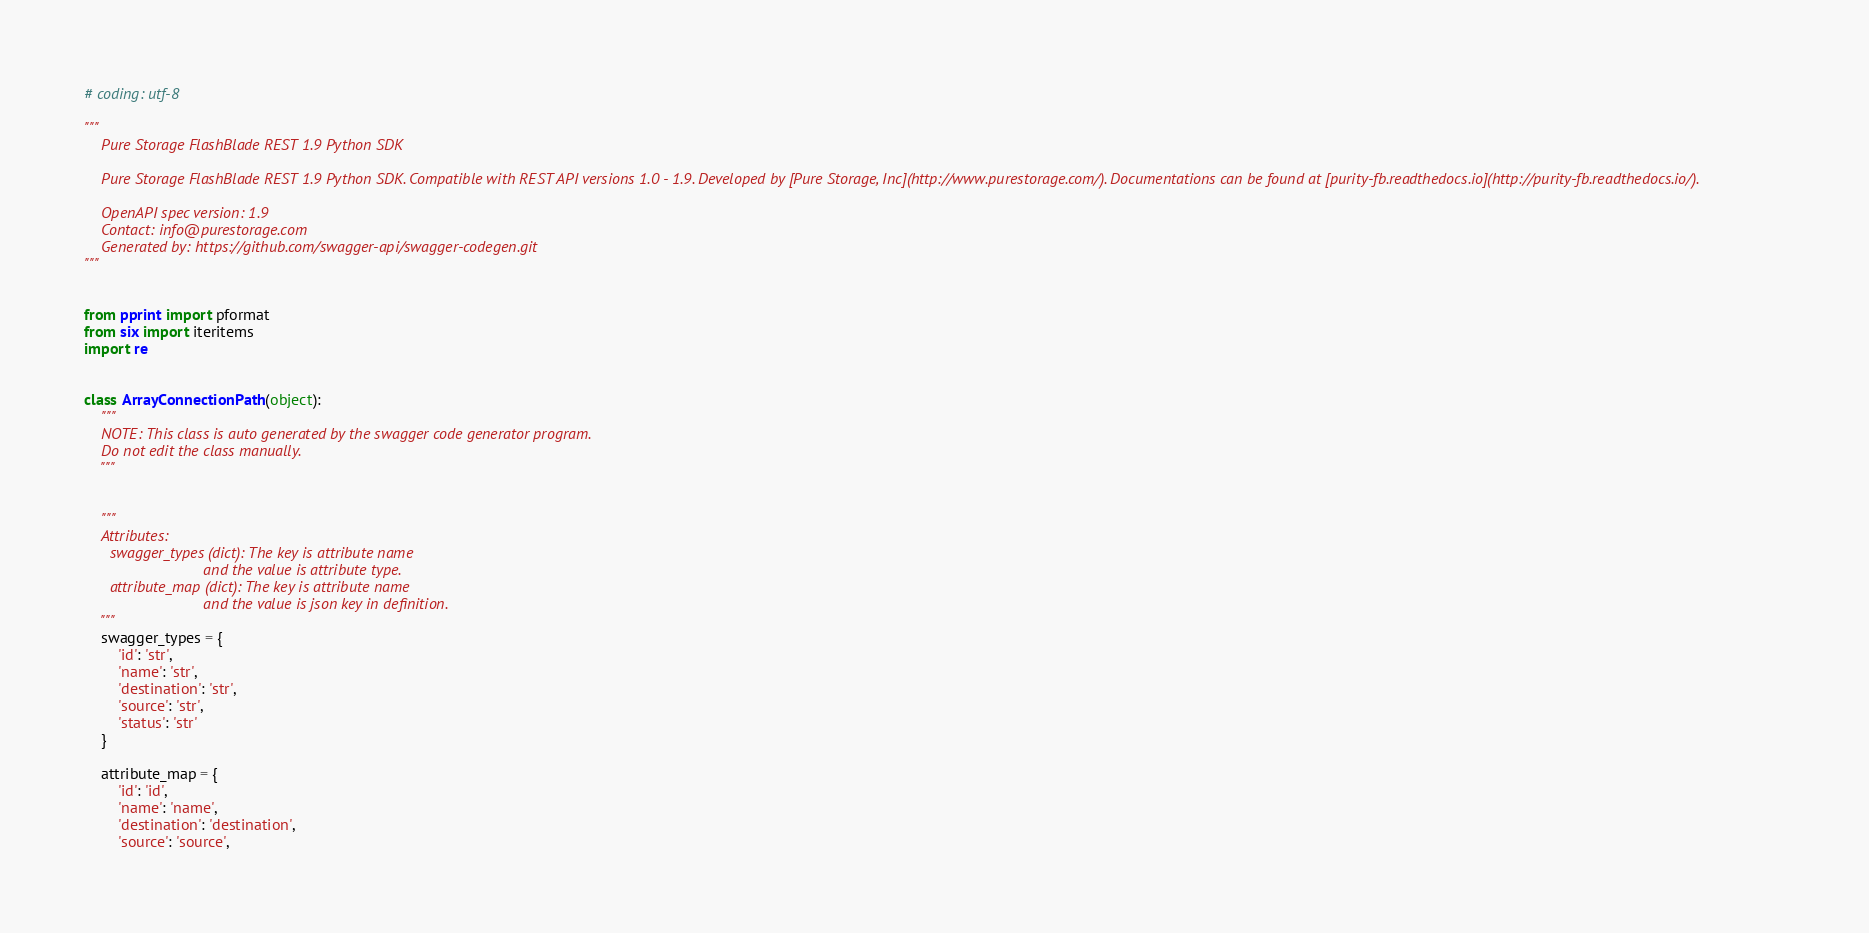Convert code to text. <code><loc_0><loc_0><loc_500><loc_500><_Python_># coding: utf-8

"""
    Pure Storage FlashBlade REST 1.9 Python SDK

    Pure Storage FlashBlade REST 1.9 Python SDK. Compatible with REST API versions 1.0 - 1.9. Developed by [Pure Storage, Inc](http://www.purestorage.com/). Documentations can be found at [purity-fb.readthedocs.io](http://purity-fb.readthedocs.io/).

    OpenAPI spec version: 1.9
    Contact: info@purestorage.com
    Generated by: https://github.com/swagger-api/swagger-codegen.git
"""


from pprint import pformat
from six import iteritems
import re


class ArrayConnectionPath(object):
    """
    NOTE: This class is auto generated by the swagger code generator program.
    Do not edit the class manually.
    """


    """
    Attributes:
      swagger_types (dict): The key is attribute name
                            and the value is attribute type.
      attribute_map (dict): The key is attribute name
                            and the value is json key in definition.
    """
    swagger_types = {
        'id': 'str',
        'name': 'str',
        'destination': 'str',
        'source': 'str',
        'status': 'str'
    }

    attribute_map = {
        'id': 'id',
        'name': 'name',
        'destination': 'destination',
        'source': 'source',</code> 